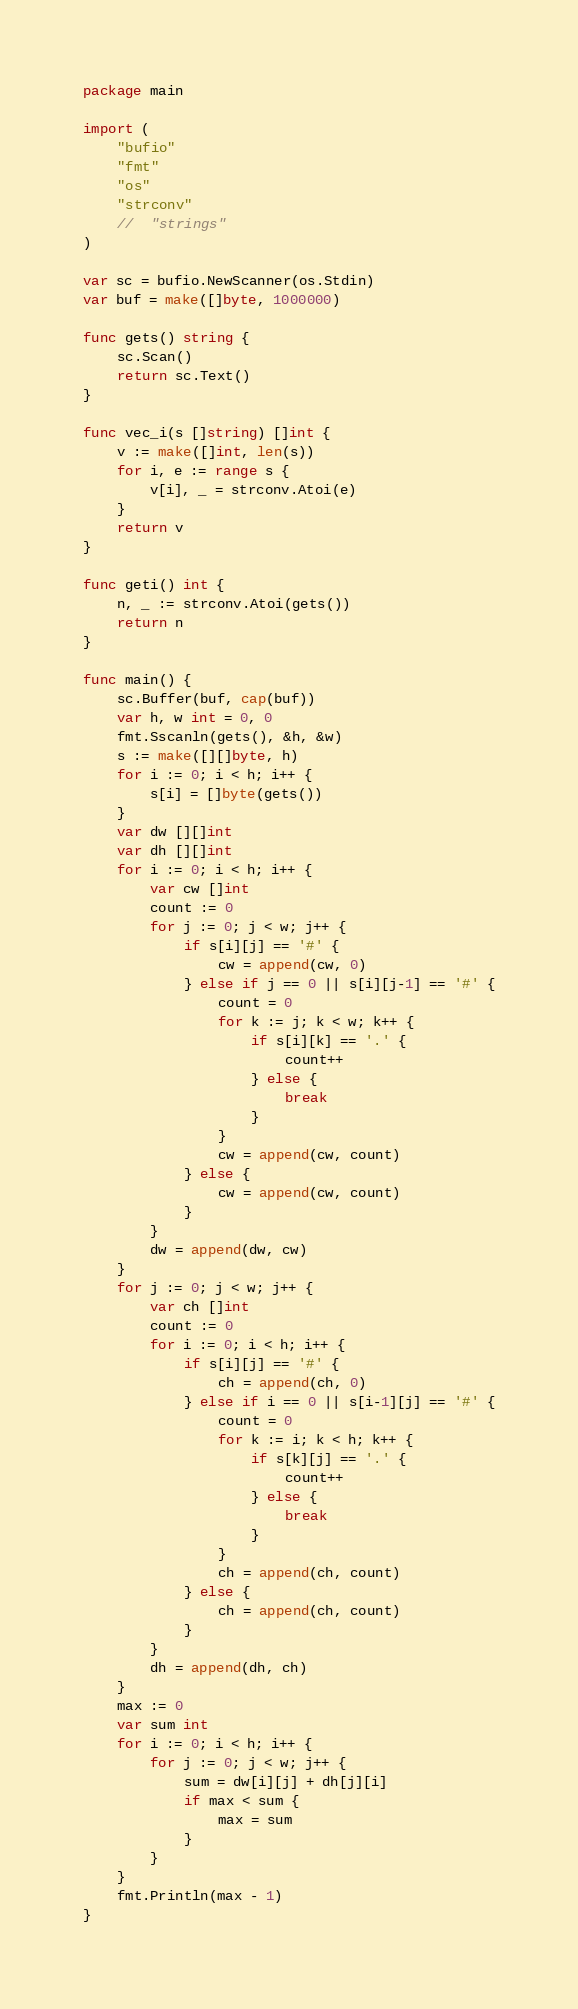Convert code to text. <code><loc_0><loc_0><loc_500><loc_500><_Go_>package main

import (
	"bufio"
	"fmt"
	"os"
	"strconv"
	//	"strings"
)

var sc = bufio.NewScanner(os.Stdin)
var buf = make([]byte, 1000000)

func gets() string {
	sc.Scan()
	return sc.Text()
}

func vec_i(s []string) []int {
	v := make([]int, len(s))
	for i, e := range s {
		v[i], _ = strconv.Atoi(e)
	}
	return v
}

func geti() int {
	n, _ := strconv.Atoi(gets())
	return n
}

func main() {
	sc.Buffer(buf, cap(buf))
	var h, w int = 0, 0
	fmt.Sscanln(gets(), &h, &w)
	s := make([][]byte, h)
	for i := 0; i < h; i++ {
		s[i] = []byte(gets())
	}
	var dw [][]int
	var dh [][]int
	for i := 0; i < h; i++ {
		var cw []int
		count := 0
		for j := 0; j < w; j++ {
			if s[i][j] == '#' {
				cw = append(cw, 0)
			} else if j == 0 || s[i][j-1] == '#' {
				count = 0
				for k := j; k < w; k++ {
					if s[i][k] == '.' {
						count++
					} else {
						break
					}
				}
				cw = append(cw, count)
			} else {
				cw = append(cw, count)
			}
		}
		dw = append(dw, cw)
	}
	for j := 0; j < w; j++ {
		var ch []int
		count := 0
		for i := 0; i < h; i++ {
			if s[i][j] == '#' {
				ch = append(ch, 0)
			} else if i == 0 || s[i-1][j] == '#' {
				count = 0
				for k := i; k < h; k++ {
					if s[k][j] == '.' {
						count++
					} else {
						break
					}
				}
				ch = append(ch, count)
			} else {
				ch = append(ch, count)
			}
		}
		dh = append(dh, ch)
	}
	max := 0
	var sum int
	for i := 0; i < h; i++ {
		for j := 0; j < w; j++ {
			sum = dw[i][j] + dh[j][i]
			if max < sum {
				max = sum
			}
		}
	}
	fmt.Println(max - 1)
}
</code> 